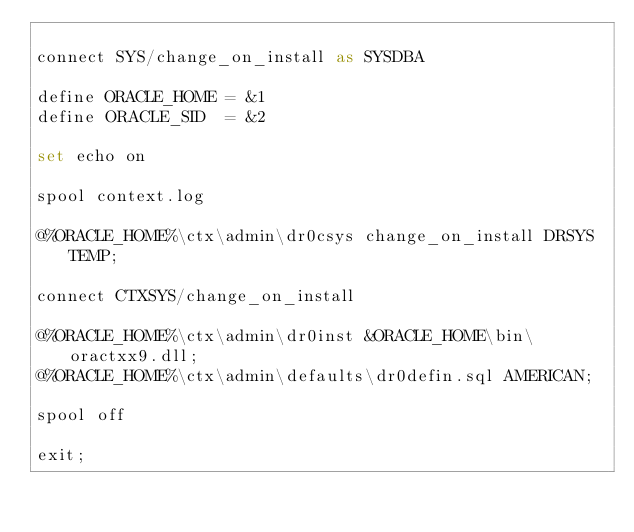Convert code to text. <code><loc_0><loc_0><loc_500><loc_500><_SQL_>
connect SYS/change_on_install as SYSDBA

define ORACLE_HOME = &1
define ORACLE_SID  = &2

set echo on

spool context.log

@%ORACLE_HOME%\ctx\admin\dr0csys change_on_install DRSYS TEMP;

connect CTXSYS/change_on_install

@%ORACLE_HOME%\ctx\admin\dr0inst &ORACLE_HOME\bin\oractxx9.dll;
@%ORACLE_HOME%\ctx\admin\defaults\dr0defin.sql AMERICAN;

spool off

exit;
</code> 